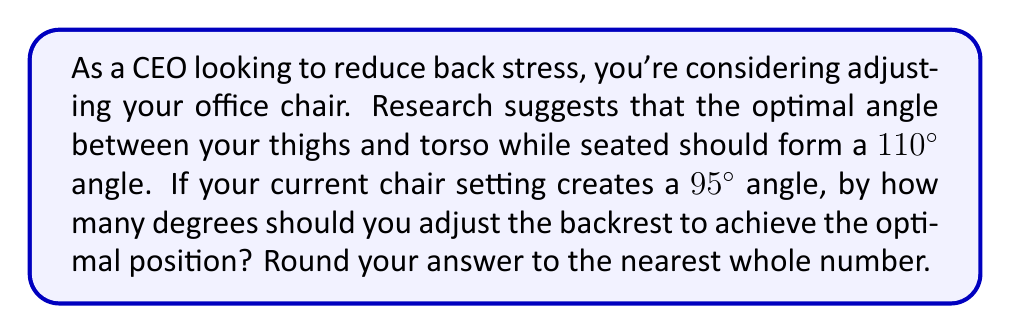Provide a solution to this math problem. To solve this problem, we need to follow these steps:

1) Identify the given information:
   - Optimal angle between thighs and torso: 110°
   - Current angle: 95°

2) Calculate the difference:
   $$\text{Adjustment needed} = \text{Optimal angle} - \text{Current angle}$$
   $$\text{Adjustment needed} = 110° - 95°$$
   $$\text{Adjustment needed} = 15°$$

3) Round to the nearest whole number:
   15° is already a whole number, so no rounding is necessary.

[asy]
import geometry;

size(200);
pair A = (0,0), B = (100,0), C = (100,100);
draw(A--B--C--A);
label("95°", (50,50), E);
draw(arc(B, 40, 0, 95), blue);
pair D = rotate(15, B)*C;
draw(B--D, red);
label("110°", (70,70), NE);
draw(arc(B, 60, 0, 110), red);
label("15°", (105,50), E);
draw(arc(B, 20, 95, 110), green);
[/asy]

The diagram above illustrates the current chair position (blue), the optimal position (red), and the adjustment needed (green).
Answer: 15° 